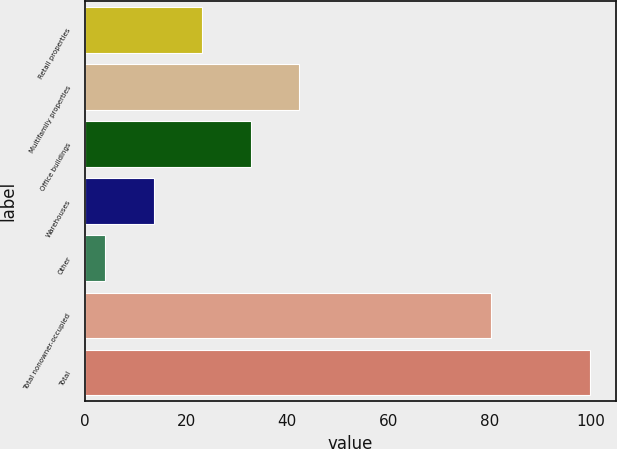Convert chart. <chart><loc_0><loc_0><loc_500><loc_500><bar_chart><fcel>Retail properties<fcel>Multifamily properties<fcel>Office buildings<fcel>Warehouses<fcel>Other<fcel>Total nonowner-occupied<fcel>Total<nl><fcel>23.2<fcel>42.4<fcel>32.8<fcel>13.6<fcel>4<fcel>80.3<fcel>100<nl></chart> 